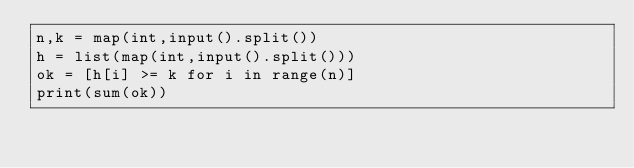<code> <loc_0><loc_0><loc_500><loc_500><_Python_>n,k = map(int,input().split())
h = list(map(int,input().split()))
ok = [h[i] >= k for i in range(n)]
print(sum(ok))</code> 